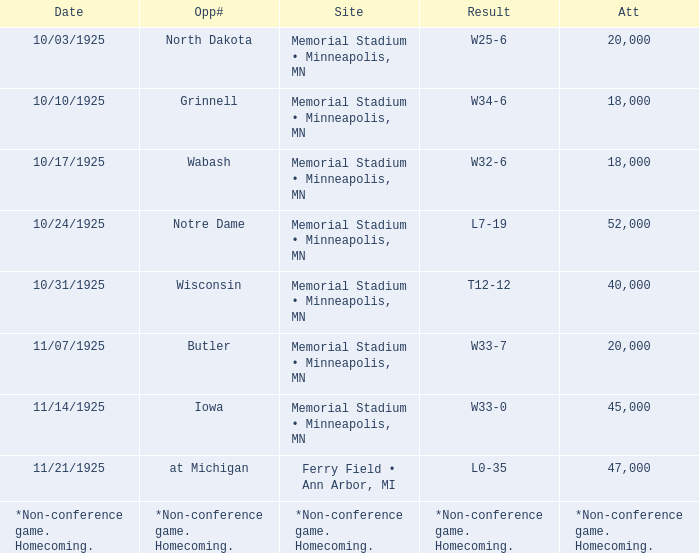Who was the opponent at the game attended by 45,000? Iowa. 